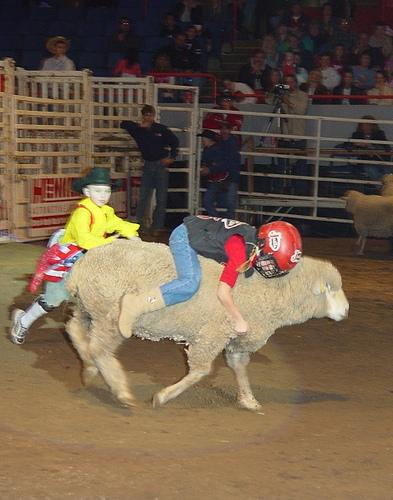Why are the little people riding the sheep? rodeo 